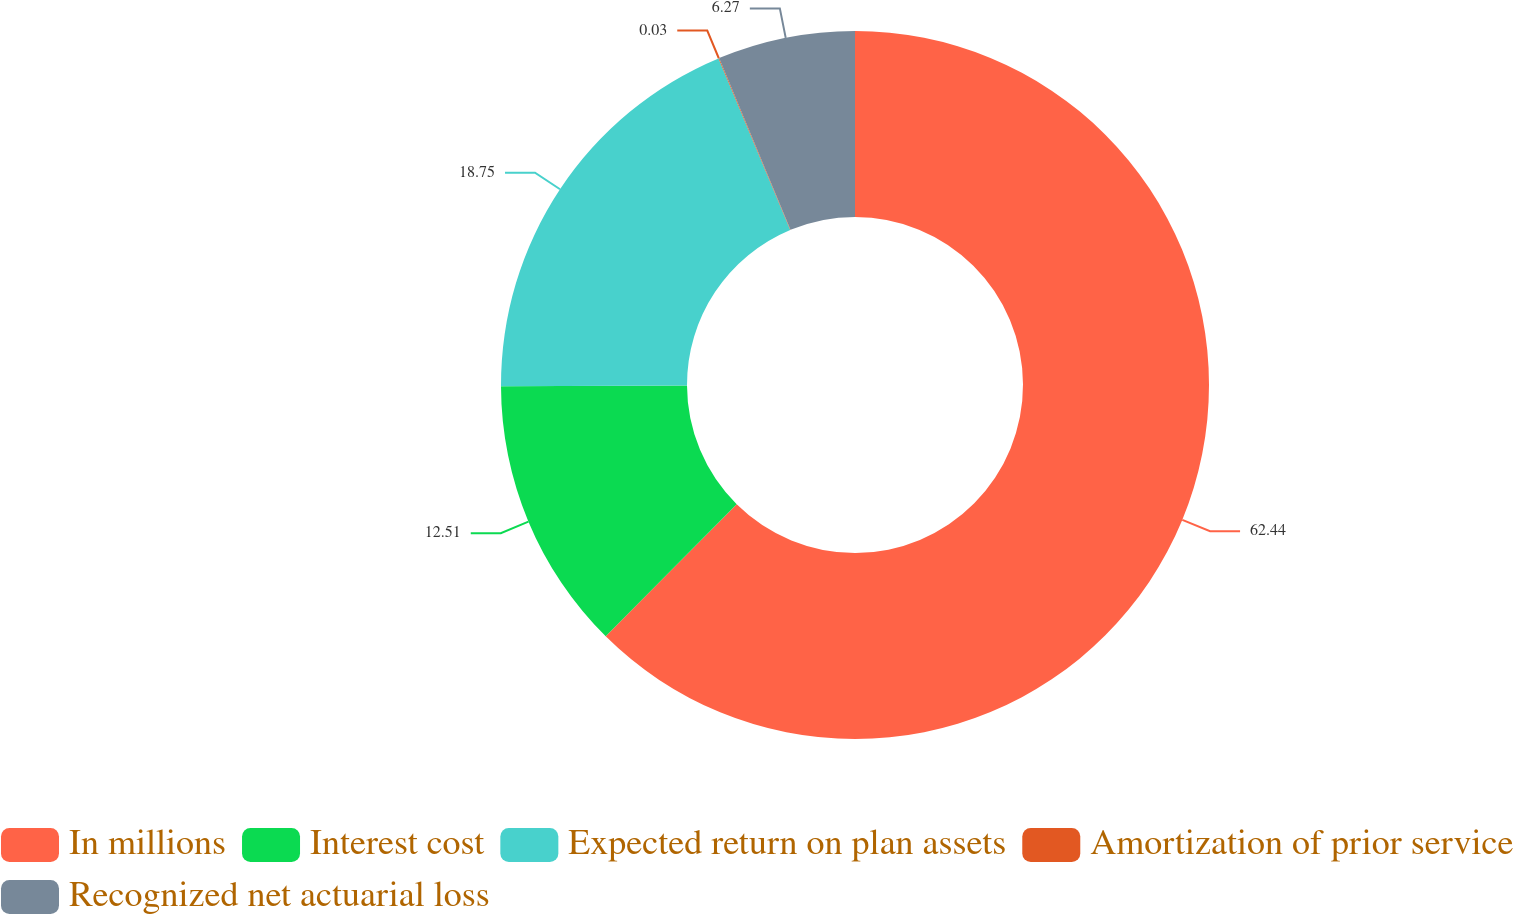Convert chart to OTSL. <chart><loc_0><loc_0><loc_500><loc_500><pie_chart><fcel>In millions<fcel>Interest cost<fcel>Expected return on plan assets<fcel>Amortization of prior service<fcel>Recognized net actuarial loss<nl><fcel>62.43%<fcel>12.51%<fcel>18.75%<fcel>0.03%<fcel>6.27%<nl></chart> 